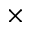<formula> <loc_0><loc_0><loc_500><loc_500>\times</formula> 